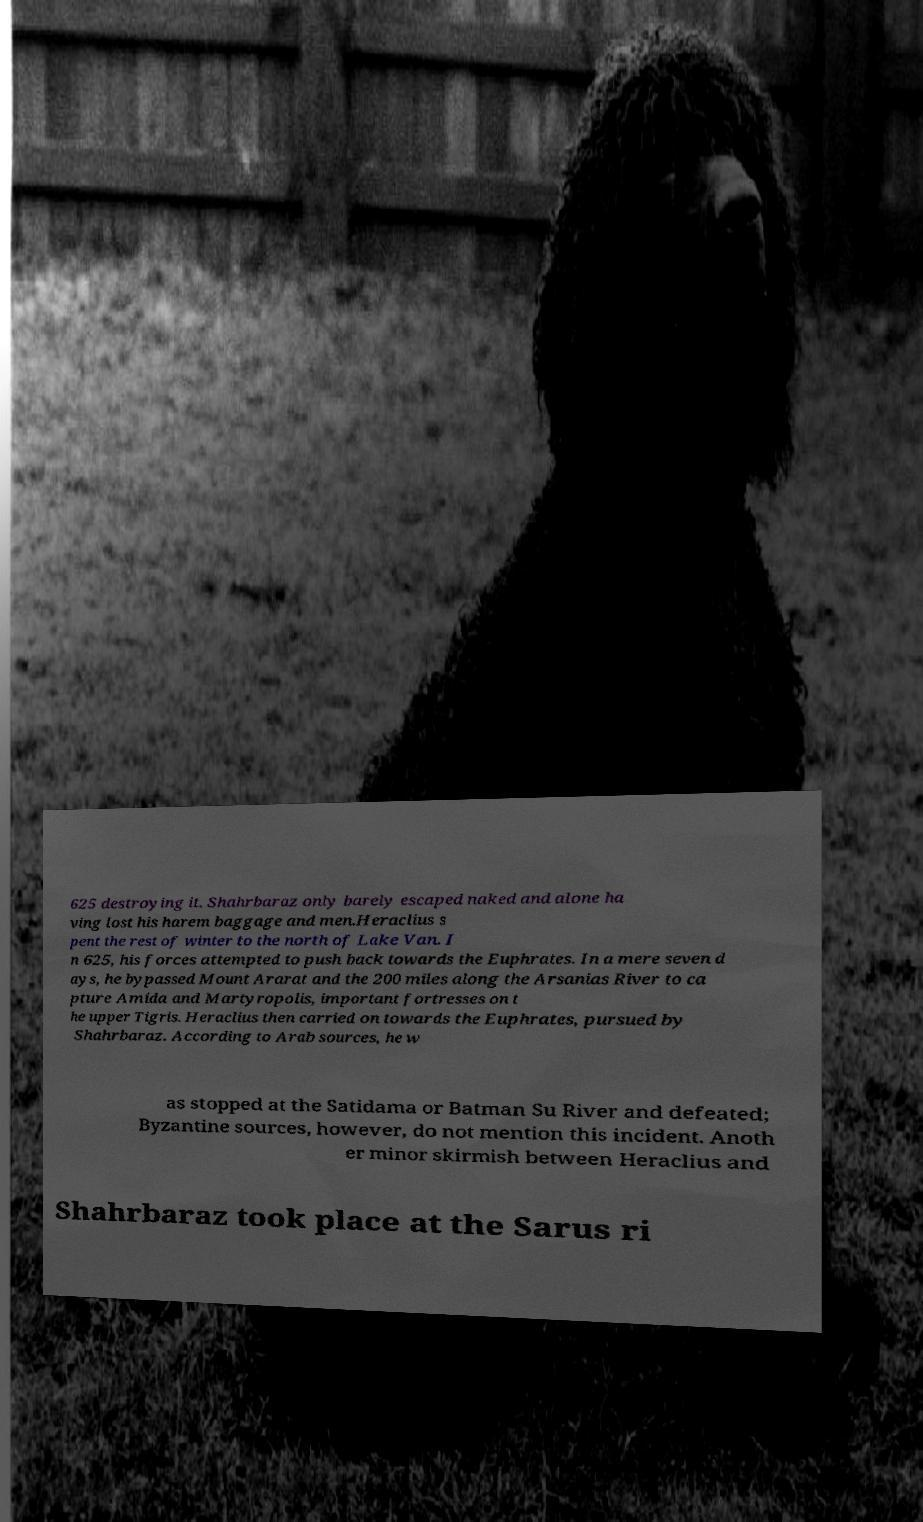Can you accurately transcribe the text from the provided image for me? 625 destroying it. Shahrbaraz only barely escaped naked and alone ha ving lost his harem baggage and men.Heraclius s pent the rest of winter to the north of Lake Van. I n 625, his forces attempted to push back towards the Euphrates. In a mere seven d ays, he bypassed Mount Ararat and the 200 miles along the Arsanias River to ca pture Amida and Martyropolis, important fortresses on t he upper Tigris. Heraclius then carried on towards the Euphrates, pursued by Shahrbaraz. According to Arab sources, he w as stopped at the Satidama or Batman Su River and defeated; Byzantine sources, however, do not mention this incident. Anoth er minor skirmish between Heraclius and Shahrbaraz took place at the Sarus ri 